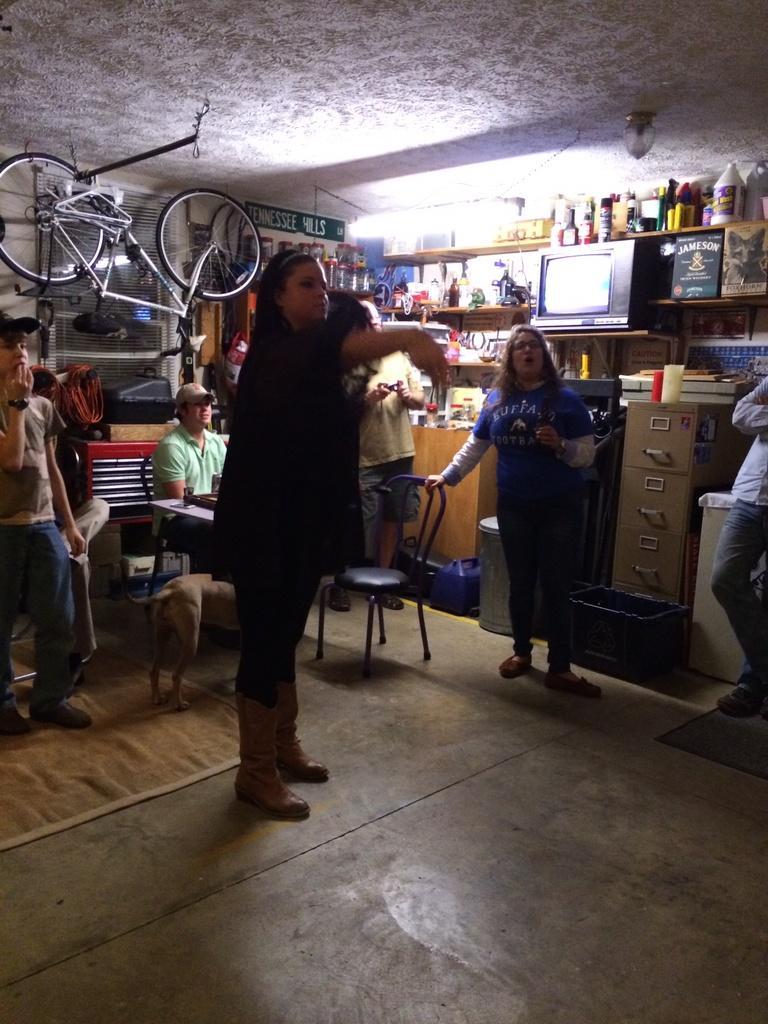Can you describe this image briefly? In this picture we can see a group of people standing on the floor and a man is sitting on a chair. Behind the people, there is a bicycle, bottles, cup, wall and other things. 